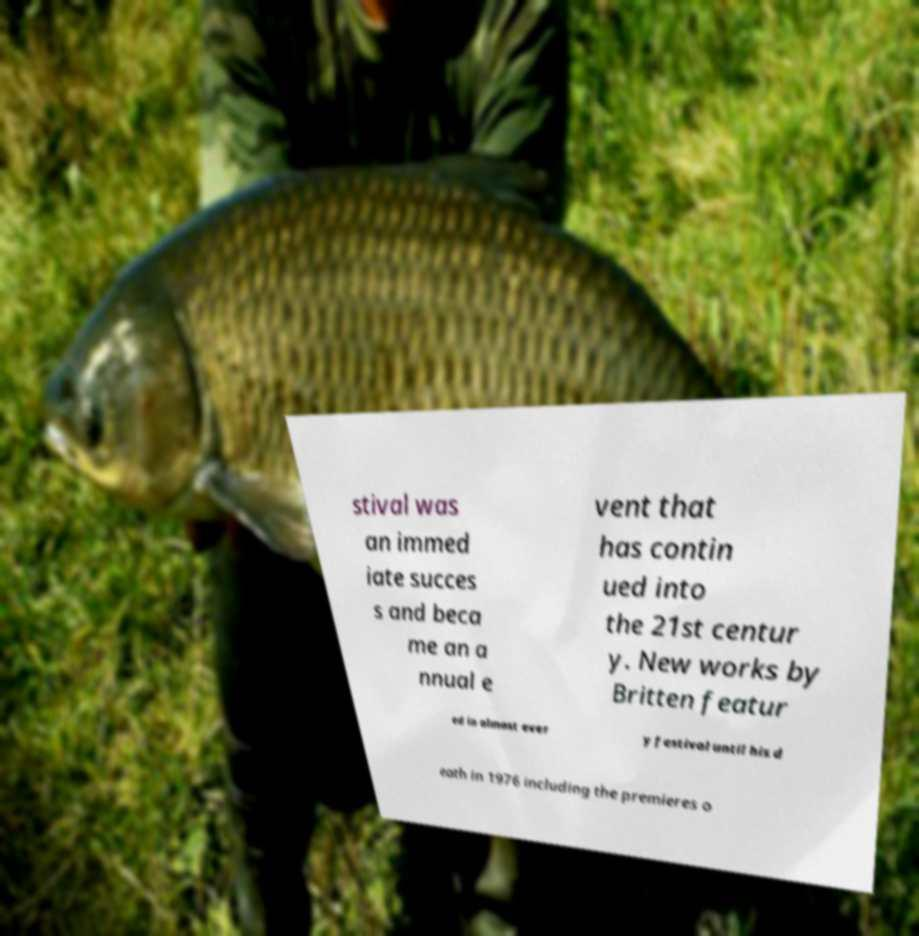For documentation purposes, I need the text within this image transcribed. Could you provide that? stival was an immed iate succes s and beca me an a nnual e vent that has contin ued into the 21st centur y. New works by Britten featur ed in almost ever y festival until his d eath in 1976 including the premieres o 